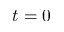<formula> <loc_0><loc_0><loc_500><loc_500>t = 0</formula> 